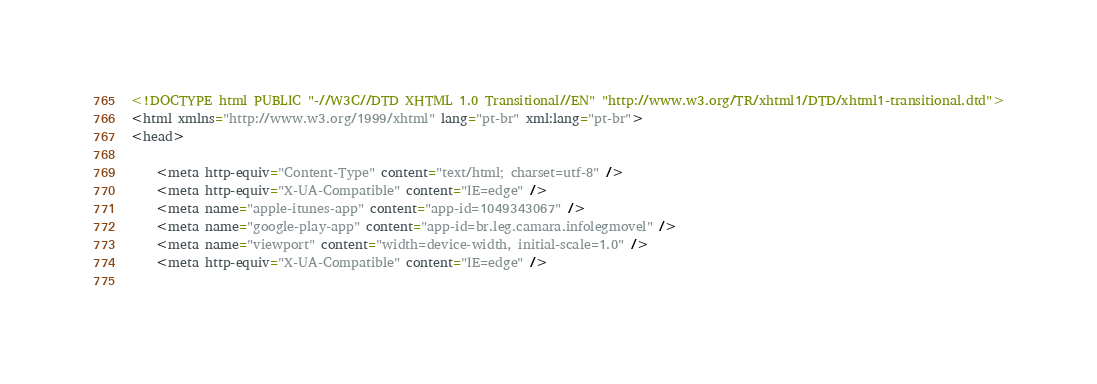Convert code to text. <code><loc_0><loc_0><loc_500><loc_500><_HTML_>




<!DOCTYPE html PUBLIC "-//W3C//DTD XHTML 1.0 Transitional//EN" "http://www.w3.org/TR/xhtml1/DTD/xhtml1-transitional.dtd">
<html xmlns="http://www.w3.org/1999/xhtml" lang="pt-br" xml:lang="pt-br">
<head>
	    
    <meta http-equiv="Content-Type" content="text/html; charset=utf-8" />
    <meta http-equiv="X-UA-Compatible" content="IE=edge" />
    <meta name="apple-itunes-app" content="app-id=1049343067" />
    <meta name="google-play-app" content="app-id=br.leg.camara.infolegmovel" />
    <meta name="viewport" content="width=device-width, initial-scale=1.0" />
	<meta http-equiv="X-UA-Compatible" content="IE=edge" /> 
    </code> 